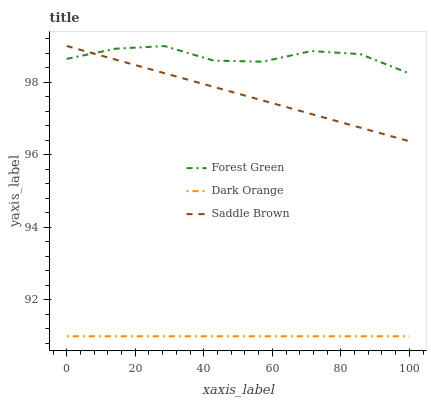Does Dark Orange have the minimum area under the curve?
Answer yes or no. Yes. Does Forest Green have the maximum area under the curve?
Answer yes or no. Yes. Does Saddle Brown have the minimum area under the curve?
Answer yes or no. No. Does Saddle Brown have the maximum area under the curve?
Answer yes or no. No. Is Dark Orange the smoothest?
Answer yes or no. Yes. Is Forest Green the roughest?
Answer yes or no. Yes. Is Saddle Brown the smoothest?
Answer yes or no. No. Is Saddle Brown the roughest?
Answer yes or no. No. Does Saddle Brown have the lowest value?
Answer yes or no. No. Does Forest Green have the highest value?
Answer yes or no. No. Is Dark Orange less than Saddle Brown?
Answer yes or no. Yes. Is Forest Green greater than Dark Orange?
Answer yes or no. Yes. Does Dark Orange intersect Saddle Brown?
Answer yes or no. No. 